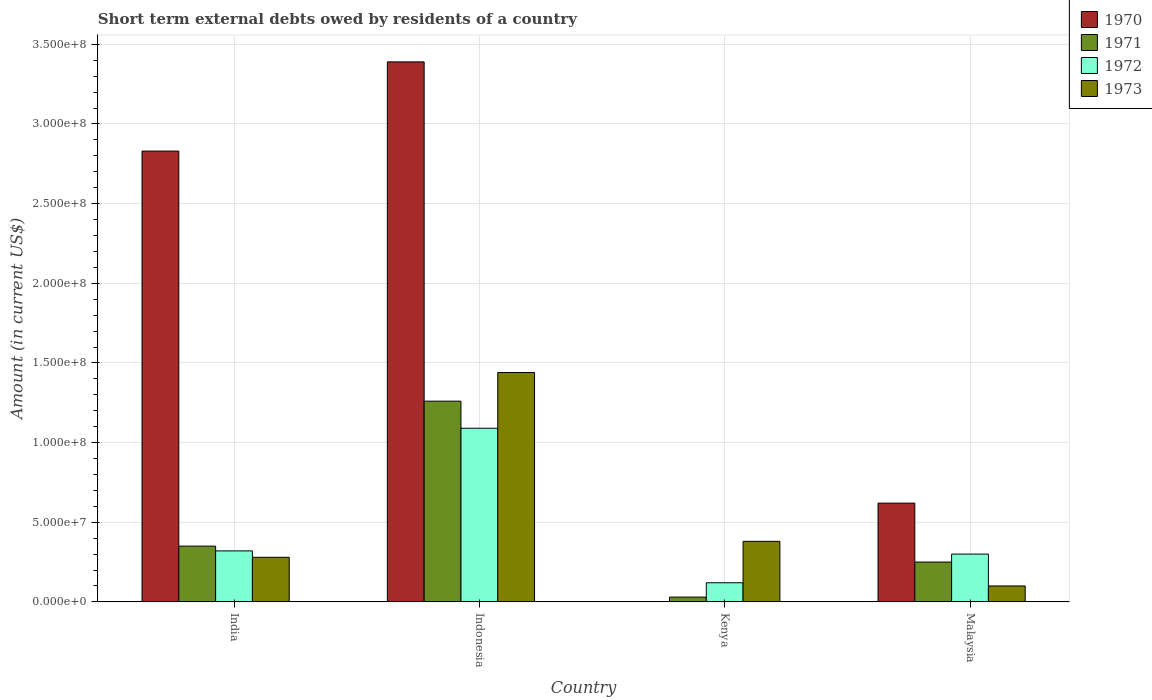How many groups of bars are there?
Offer a very short reply. 4. Are the number of bars per tick equal to the number of legend labels?
Offer a very short reply. No. Are the number of bars on each tick of the X-axis equal?
Provide a succinct answer. No. How many bars are there on the 3rd tick from the left?
Ensure brevity in your answer.  3. What is the label of the 2nd group of bars from the left?
Offer a very short reply. Indonesia. What is the amount of short-term external debts owed by residents in 1973 in Indonesia?
Provide a short and direct response. 1.44e+08. Across all countries, what is the maximum amount of short-term external debts owed by residents in 1972?
Offer a terse response. 1.09e+08. Across all countries, what is the minimum amount of short-term external debts owed by residents in 1972?
Offer a terse response. 1.20e+07. In which country was the amount of short-term external debts owed by residents in 1973 maximum?
Offer a very short reply. Indonesia. What is the total amount of short-term external debts owed by residents in 1973 in the graph?
Provide a short and direct response. 2.20e+08. What is the difference between the amount of short-term external debts owed by residents in 1971 in India and that in Indonesia?
Give a very brief answer. -9.10e+07. What is the difference between the amount of short-term external debts owed by residents in 1972 in Malaysia and the amount of short-term external debts owed by residents in 1973 in India?
Make the answer very short. 2.00e+06. What is the average amount of short-term external debts owed by residents in 1970 per country?
Keep it short and to the point. 1.71e+08. What is the difference between the amount of short-term external debts owed by residents of/in 1973 and amount of short-term external debts owed by residents of/in 1972 in Indonesia?
Provide a succinct answer. 3.50e+07. What is the ratio of the amount of short-term external debts owed by residents in 1973 in Indonesia to that in Kenya?
Provide a succinct answer. 3.79. Is the amount of short-term external debts owed by residents in 1971 in Kenya less than that in Malaysia?
Your answer should be very brief. Yes. What is the difference between the highest and the second highest amount of short-term external debts owed by residents in 1970?
Your response must be concise. 2.77e+08. What is the difference between the highest and the lowest amount of short-term external debts owed by residents in 1970?
Make the answer very short. 3.39e+08. In how many countries, is the amount of short-term external debts owed by residents in 1973 greater than the average amount of short-term external debts owed by residents in 1973 taken over all countries?
Your response must be concise. 1. How many countries are there in the graph?
Your answer should be compact. 4. What is the difference between two consecutive major ticks on the Y-axis?
Provide a succinct answer. 5.00e+07. Does the graph contain any zero values?
Provide a short and direct response. Yes. Does the graph contain grids?
Provide a succinct answer. Yes. How are the legend labels stacked?
Give a very brief answer. Vertical. What is the title of the graph?
Make the answer very short. Short term external debts owed by residents of a country. What is the label or title of the X-axis?
Offer a terse response. Country. What is the Amount (in current US$) of 1970 in India?
Give a very brief answer. 2.83e+08. What is the Amount (in current US$) in 1971 in India?
Your answer should be very brief. 3.50e+07. What is the Amount (in current US$) in 1972 in India?
Offer a very short reply. 3.20e+07. What is the Amount (in current US$) of 1973 in India?
Offer a very short reply. 2.80e+07. What is the Amount (in current US$) of 1970 in Indonesia?
Make the answer very short. 3.39e+08. What is the Amount (in current US$) of 1971 in Indonesia?
Provide a short and direct response. 1.26e+08. What is the Amount (in current US$) in 1972 in Indonesia?
Give a very brief answer. 1.09e+08. What is the Amount (in current US$) of 1973 in Indonesia?
Your answer should be compact. 1.44e+08. What is the Amount (in current US$) of 1972 in Kenya?
Your answer should be compact. 1.20e+07. What is the Amount (in current US$) in 1973 in Kenya?
Offer a terse response. 3.80e+07. What is the Amount (in current US$) in 1970 in Malaysia?
Offer a terse response. 6.20e+07. What is the Amount (in current US$) in 1971 in Malaysia?
Ensure brevity in your answer.  2.50e+07. What is the Amount (in current US$) of 1972 in Malaysia?
Your answer should be compact. 3.00e+07. What is the Amount (in current US$) in 1973 in Malaysia?
Keep it short and to the point. 1.00e+07. Across all countries, what is the maximum Amount (in current US$) of 1970?
Your response must be concise. 3.39e+08. Across all countries, what is the maximum Amount (in current US$) of 1971?
Offer a very short reply. 1.26e+08. Across all countries, what is the maximum Amount (in current US$) in 1972?
Ensure brevity in your answer.  1.09e+08. Across all countries, what is the maximum Amount (in current US$) in 1973?
Keep it short and to the point. 1.44e+08. Across all countries, what is the minimum Amount (in current US$) of 1970?
Ensure brevity in your answer.  0. What is the total Amount (in current US$) of 1970 in the graph?
Provide a short and direct response. 6.84e+08. What is the total Amount (in current US$) in 1971 in the graph?
Ensure brevity in your answer.  1.89e+08. What is the total Amount (in current US$) in 1972 in the graph?
Provide a succinct answer. 1.83e+08. What is the total Amount (in current US$) in 1973 in the graph?
Provide a short and direct response. 2.20e+08. What is the difference between the Amount (in current US$) in 1970 in India and that in Indonesia?
Your answer should be compact. -5.60e+07. What is the difference between the Amount (in current US$) of 1971 in India and that in Indonesia?
Provide a succinct answer. -9.10e+07. What is the difference between the Amount (in current US$) of 1972 in India and that in Indonesia?
Your answer should be compact. -7.70e+07. What is the difference between the Amount (in current US$) in 1973 in India and that in Indonesia?
Your answer should be compact. -1.16e+08. What is the difference between the Amount (in current US$) of 1971 in India and that in Kenya?
Your response must be concise. 3.20e+07. What is the difference between the Amount (in current US$) in 1972 in India and that in Kenya?
Ensure brevity in your answer.  2.00e+07. What is the difference between the Amount (in current US$) in 1973 in India and that in Kenya?
Your answer should be compact. -1.00e+07. What is the difference between the Amount (in current US$) of 1970 in India and that in Malaysia?
Ensure brevity in your answer.  2.21e+08. What is the difference between the Amount (in current US$) of 1973 in India and that in Malaysia?
Your response must be concise. 1.80e+07. What is the difference between the Amount (in current US$) in 1971 in Indonesia and that in Kenya?
Make the answer very short. 1.23e+08. What is the difference between the Amount (in current US$) in 1972 in Indonesia and that in Kenya?
Your answer should be very brief. 9.70e+07. What is the difference between the Amount (in current US$) of 1973 in Indonesia and that in Kenya?
Offer a very short reply. 1.06e+08. What is the difference between the Amount (in current US$) in 1970 in Indonesia and that in Malaysia?
Provide a short and direct response. 2.77e+08. What is the difference between the Amount (in current US$) of 1971 in Indonesia and that in Malaysia?
Provide a succinct answer. 1.01e+08. What is the difference between the Amount (in current US$) of 1972 in Indonesia and that in Malaysia?
Offer a very short reply. 7.90e+07. What is the difference between the Amount (in current US$) in 1973 in Indonesia and that in Malaysia?
Keep it short and to the point. 1.34e+08. What is the difference between the Amount (in current US$) in 1971 in Kenya and that in Malaysia?
Your response must be concise. -2.20e+07. What is the difference between the Amount (in current US$) in 1972 in Kenya and that in Malaysia?
Give a very brief answer. -1.80e+07. What is the difference between the Amount (in current US$) in 1973 in Kenya and that in Malaysia?
Your answer should be compact. 2.80e+07. What is the difference between the Amount (in current US$) of 1970 in India and the Amount (in current US$) of 1971 in Indonesia?
Provide a short and direct response. 1.57e+08. What is the difference between the Amount (in current US$) of 1970 in India and the Amount (in current US$) of 1972 in Indonesia?
Provide a short and direct response. 1.74e+08. What is the difference between the Amount (in current US$) of 1970 in India and the Amount (in current US$) of 1973 in Indonesia?
Provide a short and direct response. 1.39e+08. What is the difference between the Amount (in current US$) in 1971 in India and the Amount (in current US$) in 1972 in Indonesia?
Provide a short and direct response. -7.40e+07. What is the difference between the Amount (in current US$) in 1971 in India and the Amount (in current US$) in 1973 in Indonesia?
Offer a terse response. -1.09e+08. What is the difference between the Amount (in current US$) of 1972 in India and the Amount (in current US$) of 1973 in Indonesia?
Your response must be concise. -1.12e+08. What is the difference between the Amount (in current US$) in 1970 in India and the Amount (in current US$) in 1971 in Kenya?
Provide a short and direct response. 2.80e+08. What is the difference between the Amount (in current US$) in 1970 in India and the Amount (in current US$) in 1972 in Kenya?
Your answer should be compact. 2.71e+08. What is the difference between the Amount (in current US$) in 1970 in India and the Amount (in current US$) in 1973 in Kenya?
Give a very brief answer. 2.45e+08. What is the difference between the Amount (in current US$) in 1971 in India and the Amount (in current US$) in 1972 in Kenya?
Make the answer very short. 2.30e+07. What is the difference between the Amount (in current US$) of 1971 in India and the Amount (in current US$) of 1973 in Kenya?
Your answer should be compact. -3.00e+06. What is the difference between the Amount (in current US$) in 1972 in India and the Amount (in current US$) in 1973 in Kenya?
Offer a very short reply. -6.00e+06. What is the difference between the Amount (in current US$) of 1970 in India and the Amount (in current US$) of 1971 in Malaysia?
Give a very brief answer. 2.58e+08. What is the difference between the Amount (in current US$) of 1970 in India and the Amount (in current US$) of 1972 in Malaysia?
Provide a short and direct response. 2.53e+08. What is the difference between the Amount (in current US$) of 1970 in India and the Amount (in current US$) of 1973 in Malaysia?
Your response must be concise. 2.73e+08. What is the difference between the Amount (in current US$) of 1971 in India and the Amount (in current US$) of 1973 in Malaysia?
Make the answer very short. 2.50e+07. What is the difference between the Amount (in current US$) in 1972 in India and the Amount (in current US$) in 1973 in Malaysia?
Provide a succinct answer. 2.20e+07. What is the difference between the Amount (in current US$) in 1970 in Indonesia and the Amount (in current US$) in 1971 in Kenya?
Your answer should be compact. 3.36e+08. What is the difference between the Amount (in current US$) in 1970 in Indonesia and the Amount (in current US$) in 1972 in Kenya?
Your response must be concise. 3.27e+08. What is the difference between the Amount (in current US$) of 1970 in Indonesia and the Amount (in current US$) of 1973 in Kenya?
Offer a terse response. 3.01e+08. What is the difference between the Amount (in current US$) of 1971 in Indonesia and the Amount (in current US$) of 1972 in Kenya?
Keep it short and to the point. 1.14e+08. What is the difference between the Amount (in current US$) of 1971 in Indonesia and the Amount (in current US$) of 1973 in Kenya?
Your answer should be very brief. 8.80e+07. What is the difference between the Amount (in current US$) in 1972 in Indonesia and the Amount (in current US$) in 1973 in Kenya?
Ensure brevity in your answer.  7.10e+07. What is the difference between the Amount (in current US$) in 1970 in Indonesia and the Amount (in current US$) in 1971 in Malaysia?
Keep it short and to the point. 3.14e+08. What is the difference between the Amount (in current US$) in 1970 in Indonesia and the Amount (in current US$) in 1972 in Malaysia?
Your answer should be very brief. 3.09e+08. What is the difference between the Amount (in current US$) in 1970 in Indonesia and the Amount (in current US$) in 1973 in Malaysia?
Ensure brevity in your answer.  3.29e+08. What is the difference between the Amount (in current US$) in 1971 in Indonesia and the Amount (in current US$) in 1972 in Malaysia?
Offer a very short reply. 9.60e+07. What is the difference between the Amount (in current US$) in 1971 in Indonesia and the Amount (in current US$) in 1973 in Malaysia?
Give a very brief answer. 1.16e+08. What is the difference between the Amount (in current US$) of 1972 in Indonesia and the Amount (in current US$) of 1973 in Malaysia?
Your answer should be very brief. 9.90e+07. What is the difference between the Amount (in current US$) of 1971 in Kenya and the Amount (in current US$) of 1972 in Malaysia?
Keep it short and to the point. -2.70e+07. What is the difference between the Amount (in current US$) of 1971 in Kenya and the Amount (in current US$) of 1973 in Malaysia?
Your answer should be very brief. -7.00e+06. What is the difference between the Amount (in current US$) in 1972 in Kenya and the Amount (in current US$) in 1973 in Malaysia?
Your answer should be compact. 2.00e+06. What is the average Amount (in current US$) in 1970 per country?
Provide a succinct answer. 1.71e+08. What is the average Amount (in current US$) in 1971 per country?
Provide a succinct answer. 4.72e+07. What is the average Amount (in current US$) in 1972 per country?
Keep it short and to the point. 4.58e+07. What is the average Amount (in current US$) in 1973 per country?
Offer a very short reply. 5.50e+07. What is the difference between the Amount (in current US$) of 1970 and Amount (in current US$) of 1971 in India?
Provide a short and direct response. 2.48e+08. What is the difference between the Amount (in current US$) in 1970 and Amount (in current US$) in 1972 in India?
Keep it short and to the point. 2.51e+08. What is the difference between the Amount (in current US$) of 1970 and Amount (in current US$) of 1973 in India?
Your answer should be very brief. 2.55e+08. What is the difference between the Amount (in current US$) in 1971 and Amount (in current US$) in 1972 in India?
Keep it short and to the point. 3.00e+06. What is the difference between the Amount (in current US$) in 1972 and Amount (in current US$) in 1973 in India?
Give a very brief answer. 4.00e+06. What is the difference between the Amount (in current US$) of 1970 and Amount (in current US$) of 1971 in Indonesia?
Ensure brevity in your answer.  2.13e+08. What is the difference between the Amount (in current US$) in 1970 and Amount (in current US$) in 1972 in Indonesia?
Your answer should be very brief. 2.30e+08. What is the difference between the Amount (in current US$) of 1970 and Amount (in current US$) of 1973 in Indonesia?
Provide a succinct answer. 1.95e+08. What is the difference between the Amount (in current US$) of 1971 and Amount (in current US$) of 1972 in Indonesia?
Keep it short and to the point. 1.70e+07. What is the difference between the Amount (in current US$) in 1971 and Amount (in current US$) in 1973 in Indonesia?
Ensure brevity in your answer.  -1.80e+07. What is the difference between the Amount (in current US$) in 1972 and Amount (in current US$) in 1973 in Indonesia?
Your response must be concise. -3.50e+07. What is the difference between the Amount (in current US$) in 1971 and Amount (in current US$) in 1972 in Kenya?
Your response must be concise. -9.00e+06. What is the difference between the Amount (in current US$) in 1971 and Amount (in current US$) in 1973 in Kenya?
Your answer should be compact. -3.50e+07. What is the difference between the Amount (in current US$) of 1972 and Amount (in current US$) of 1973 in Kenya?
Make the answer very short. -2.60e+07. What is the difference between the Amount (in current US$) of 1970 and Amount (in current US$) of 1971 in Malaysia?
Offer a terse response. 3.70e+07. What is the difference between the Amount (in current US$) in 1970 and Amount (in current US$) in 1972 in Malaysia?
Your response must be concise. 3.20e+07. What is the difference between the Amount (in current US$) in 1970 and Amount (in current US$) in 1973 in Malaysia?
Your response must be concise. 5.20e+07. What is the difference between the Amount (in current US$) in 1971 and Amount (in current US$) in 1972 in Malaysia?
Your answer should be very brief. -5.00e+06. What is the difference between the Amount (in current US$) in 1971 and Amount (in current US$) in 1973 in Malaysia?
Provide a short and direct response. 1.50e+07. What is the ratio of the Amount (in current US$) in 1970 in India to that in Indonesia?
Your answer should be very brief. 0.83. What is the ratio of the Amount (in current US$) in 1971 in India to that in Indonesia?
Provide a short and direct response. 0.28. What is the ratio of the Amount (in current US$) in 1972 in India to that in Indonesia?
Offer a terse response. 0.29. What is the ratio of the Amount (in current US$) of 1973 in India to that in Indonesia?
Provide a short and direct response. 0.19. What is the ratio of the Amount (in current US$) of 1971 in India to that in Kenya?
Provide a short and direct response. 11.67. What is the ratio of the Amount (in current US$) in 1972 in India to that in Kenya?
Your answer should be compact. 2.67. What is the ratio of the Amount (in current US$) of 1973 in India to that in Kenya?
Give a very brief answer. 0.74. What is the ratio of the Amount (in current US$) of 1970 in India to that in Malaysia?
Your answer should be compact. 4.56. What is the ratio of the Amount (in current US$) in 1972 in India to that in Malaysia?
Your answer should be very brief. 1.07. What is the ratio of the Amount (in current US$) of 1971 in Indonesia to that in Kenya?
Provide a short and direct response. 42. What is the ratio of the Amount (in current US$) in 1972 in Indonesia to that in Kenya?
Give a very brief answer. 9.08. What is the ratio of the Amount (in current US$) in 1973 in Indonesia to that in Kenya?
Keep it short and to the point. 3.79. What is the ratio of the Amount (in current US$) in 1970 in Indonesia to that in Malaysia?
Offer a very short reply. 5.47. What is the ratio of the Amount (in current US$) in 1971 in Indonesia to that in Malaysia?
Your answer should be very brief. 5.04. What is the ratio of the Amount (in current US$) of 1972 in Indonesia to that in Malaysia?
Your answer should be very brief. 3.63. What is the ratio of the Amount (in current US$) of 1971 in Kenya to that in Malaysia?
Your answer should be compact. 0.12. What is the ratio of the Amount (in current US$) of 1972 in Kenya to that in Malaysia?
Your response must be concise. 0.4. What is the difference between the highest and the second highest Amount (in current US$) in 1970?
Give a very brief answer. 5.60e+07. What is the difference between the highest and the second highest Amount (in current US$) of 1971?
Provide a short and direct response. 9.10e+07. What is the difference between the highest and the second highest Amount (in current US$) of 1972?
Your response must be concise. 7.70e+07. What is the difference between the highest and the second highest Amount (in current US$) in 1973?
Your answer should be compact. 1.06e+08. What is the difference between the highest and the lowest Amount (in current US$) in 1970?
Provide a succinct answer. 3.39e+08. What is the difference between the highest and the lowest Amount (in current US$) in 1971?
Give a very brief answer. 1.23e+08. What is the difference between the highest and the lowest Amount (in current US$) of 1972?
Provide a short and direct response. 9.70e+07. What is the difference between the highest and the lowest Amount (in current US$) in 1973?
Give a very brief answer. 1.34e+08. 